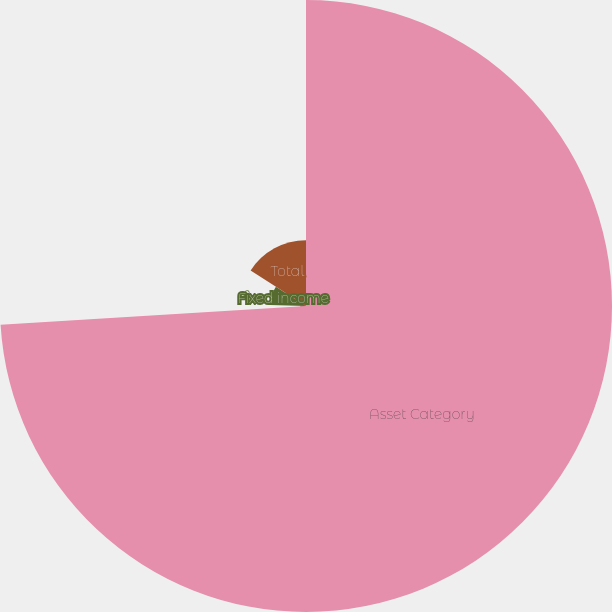<chart> <loc_0><loc_0><loc_500><loc_500><pie_chart><fcel>Asset Category<fcel>Equity securities<fcel>Fixed income<fcel>Total<nl><fcel>74.03%<fcel>1.39%<fcel>8.66%<fcel>15.92%<nl></chart> 